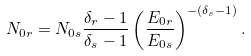Convert formula to latex. <formula><loc_0><loc_0><loc_500><loc_500>N _ { 0 r } = N _ { 0 s } \frac { \delta _ { r } - 1 } { \delta _ { s } - 1 } \left ( \frac { E _ { 0 r } } { E _ { 0 s } } \right ) ^ { - ( \delta _ { s } - 1 ) } .</formula> 